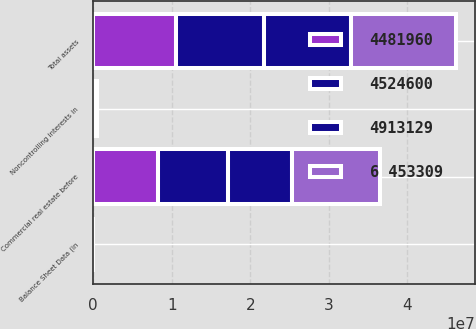<chart> <loc_0><loc_0><loc_500><loc_500><stacked_bar_chart><ecel><fcel>Balance Sheet Data (in<fcel>Commercial real estate before<fcel>Total assets<fcel>Noncontrolling interests in<nl><fcel>6 453309<fcel>2011<fcel>1.11472e+07<fcel>1.34839e+07<fcel>195030<nl><fcel>4524600<fcel>2010<fcel>8.89006e+06<fcel>1.13003e+07<fcel>84338<nl><fcel>4481960<fcel>2009<fcel>8.2571e+06<fcel>1.04876e+07<fcel>84618<nl><fcel>4913129<fcel>2008<fcel>8.20179e+06<fcel>1.09844e+07<fcel>87330<nl></chart> 